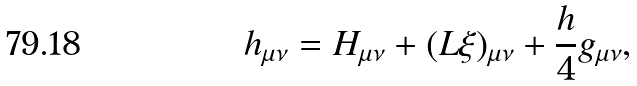<formula> <loc_0><loc_0><loc_500><loc_500>h _ { \mu \nu } = H _ { \mu \nu } + ( L \xi ) _ { \mu \nu } + \frac { h } { 4 } g _ { \mu \nu } ,</formula> 